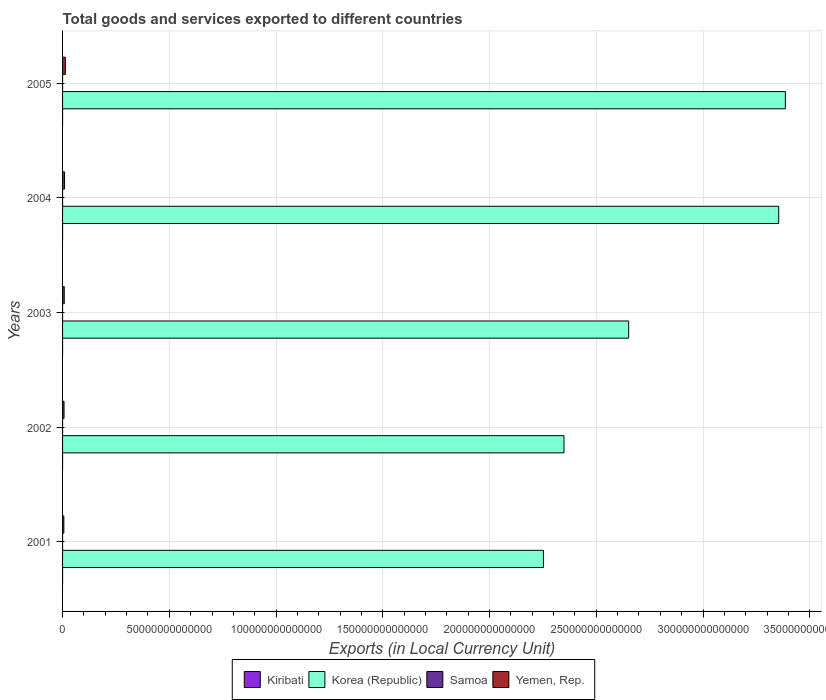How many different coloured bars are there?
Provide a short and direct response. 4. Are the number of bars on each tick of the Y-axis equal?
Offer a terse response. Yes. How many bars are there on the 1st tick from the bottom?
Provide a short and direct response. 4. In how many cases, is the number of bars for a given year not equal to the number of legend labels?
Give a very brief answer. 0. What is the Amount of goods and services exports in Korea (Republic) in 2004?
Your answer should be compact. 3.35e+14. Across all years, what is the maximum Amount of goods and services exports in Korea (Republic)?
Provide a short and direct response. 3.39e+14. Across all years, what is the minimum Amount of goods and services exports in Samoa?
Your answer should be compact. 2.88e+08. In which year was the Amount of goods and services exports in Samoa maximum?
Your answer should be compact. 2005. In which year was the Amount of goods and services exports in Kiribati minimum?
Offer a terse response. 2004. What is the total Amount of goods and services exports in Korea (Republic) in the graph?
Keep it short and to the point. 1.40e+15. What is the difference between the Amount of goods and services exports in Kiribati in 2001 and that in 2004?
Provide a succinct answer. 3.41e+06. What is the difference between the Amount of goods and services exports in Kiribati in 2005 and the Amount of goods and services exports in Korea (Republic) in 2002?
Your answer should be compact. -2.35e+14. What is the average Amount of goods and services exports in Yemen, Rep. per year?
Provide a succinct answer. 8.65e+11. In the year 2005, what is the difference between the Amount of goods and services exports in Yemen, Rep. and Amount of goods and services exports in Kiribati?
Provide a succinct answer. 1.31e+12. In how many years, is the Amount of goods and services exports in Kiribati greater than 320000000000000 LCU?
Provide a succinct answer. 0. What is the ratio of the Amount of goods and services exports in Kiribati in 2001 to that in 2002?
Your answer should be compact. 0.79. Is the difference between the Amount of goods and services exports in Yemen, Rep. in 2001 and 2003 greater than the difference between the Amount of goods and services exports in Kiribati in 2001 and 2003?
Your answer should be very brief. No. What is the difference between the highest and the second highest Amount of goods and services exports in Yemen, Rep.?
Give a very brief answer. 3.80e+11. What is the difference between the highest and the lowest Amount of goods and services exports in Yemen, Rep.?
Offer a very short reply. 7.16e+11. What does the 1st bar from the top in 2004 represents?
Provide a short and direct response. Yemen, Rep. What does the 4th bar from the bottom in 2005 represents?
Your answer should be compact. Yemen, Rep. Are all the bars in the graph horizontal?
Offer a terse response. Yes. How many years are there in the graph?
Your answer should be very brief. 5. What is the difference between two consecutive major ticks on the X-axis?
Ensure brevity in your answer.  5.00e+13. Are the values on the major ticks of X-axis written in scientific E-notation?
Make the answer very short. No. Does the graph contain grids?
Your answer should be very brief. Yes. Where does the legend appear in the graph?
Your answer should be very brief. Bottom center. How many legend labels are there?
Offer a terse response. 4. What is the title of the graph?
Ensure brevity in your answer.  Total goods and services exported to different countries. What is the label or title of the X-axis?
Provide a short and direct response. Exports (in Local Currency Unit). What is the label or title of the Y-axis?
Give a very brief answer. Years. What is the Exports (in Local Currency Unit) in Kiribati in 2001?
Make the answer very short. 1.96e+07. What is the Exports (in Local Currency Unit) in Korea (Republic) in 2001?
Give a very brief answer. 2.25e+14. What is the Exports (in Local Currency Unit) in Samoa in 2001?
Your answer should be very brief. 2.88e+08. What is the Exports (in Local Currency Unit) of Yemen, Rep. in 2001?
Your answer should be compact. 5.97e+11. What is the Exports (in Local Currency Unit) of Kiribati in 2002?
Keep it short and to the point. 2.48e+07. What is the Exports (in Local Currency Unit) in Korea (Republic) in 2002?
Provide a succinct answer. 2.35e+14. What is the Exports (in Local Currency Unit) of Samoa in 2002?
Ensure brevity in your answer.  2.93e+08. What is the Exports (in Local Currency Unit) in Yemen, Rep. in 2002?
Provide a short and direct response. 6.95e+11. What is the Exports (in Local Currency Unit) in Kiribati in 2003?
Provide a succinct answer. 2.30e+07. What is the Exports (in Local Currency Unit) in Korea (Republic) in 2003?
Provide a short and direct response. 2.65e+14. What is the Exports (in Local Currency Unit) in Samoa in 2003?
Your answer should be compact. 2.99e+08. What is the Exports (in Local Currency Unit) of Yemen, Rep. in 2003?
Give a very brief answer. 7.87e+11. What is the Exports (in Local Currency Unit) of Kiribati in 2004?
Your response must be concise. 1.62e+07. What is the Exports (in Local Currency Unit) of Korea (Republic) in 2004?
Offer a very short reply. 3.35e+14. What is the Exports (in Local Currency Unit) in Samoa in 2004?
Provide a short and direct response. 3.39e+08. What is the Exports (in Local Currency Unit) of Yemen, Rep. in 2004?
Provide a succinct answer. 9.33e+11. What is the Exports (in Local Currency Unit) of Kiribati in 2005?
Your answer should be compact. 1.96e+07. What is the Exports (in Local Currency Unit) of Korea (Republic) in 2005?
Provide a succinct answer. 3.39e+14. What is the Exports (in Local Currency Unit) of Samoa in 2005?
Your answer should be compact. 3.58e+08. What is the Exports (in Local Currency Unit) of Yemen, Rep. in 2005?
Your answer should be very brief. 1.31e+12. Across all years, what is the maximum Exports (in Local Currency Unit) of Kiribati?
Your answer should be very brief. 2.48e+07. Across all years, what is the maximum Exports (in Local Currency Unit) in Korea (Republic)?
Ensure brevity in your answer.  3.39e+14. Across all years, what is the maximum Exports (in Local Currency Unit) in Samoa?
Provide a short and direct response. 3.58e+08. Across all years, what is the maximum Exports (in Local Currency Unit) in Yemen, Rep.?
Your answer should be very brief. 1.31e+12. Across all years, what is the minimum Exports (in Local Currency Unit) in Kiribati?
Offer a very short reply. 1.62e+07. Across all years, what is the minimum Exports (in Local Currency Unit) in Korea (Republic)?
Offer a terse response. 2.25e+14. Across all years, what is the minimum Exports (in Local Currency Unit) of Samoa?
Give a very brief answer. 2.88e+08. Across all years, what is the minimum Exports (in Local Currency Unit) in Yemen, Rep.?
Make the answer very short. 5.97e+11. What is the total Exports (in Local Currency Unit) of Kiribati in the graph?
Make the answer very short. 1.03e+08. What is the total Exports (in Local Currency Unit) in Korea (Republic) in the graph?
Provide a succinct answer. 1.40e+15. What is the total Exports (in Local Currency Unit) in Samoa in the graph?
Your answer should be compact. 1.58e+09. What is the total Exports (in Local Currency Unit) in Yemen, Rep. in the graph?
Offer a terse response. 4.32e+12. What is the difference between the Exports (in Local Currency Unit) of Kiribati in 2001 and that in 2002?
Give a very brief answer. -5.25e+06. What is the difference between the Exports (in Local Currency Unit) of Korea (Republic) in 2001 and that in 2002?
Provide a short and direct response. -9.63e+12. What is the difference between the Exports (in Local Currency Unit) of Samoa in 2001 and that in 2002?
Keep it short and to the point. -4.68e+06. What is the difference between the Exports (in Local Currency Unit) of Yemen, Rep. in 2001 and that in 2002?
Give a very brief answer. -9.82e+1. What is the difference between the Exports (in Local Currency Unit) in Kiribati in 2001 and that in 2003?
Offer a very short reply. -3.41e+06. What is the difference between the Exports (in Local Currency Unit) of Korea (Republic) in 2001 and that in 2003?
Your response must be concise. -3.99e+13. What is the difference between the Exports (in Local Currency Unit) in Samoa in 2001 and that in 2003?
Provide a short and direct response. -1.08e+07. What is the difference between the Exports (in Local Currency Unit) of Yemen, Rep. in 2001 and that in 2003?
Provide a short and direct response. -1.91e+11. What is the difference between the Exports (in Local Currency Unit) of Kiribati in 2001 and that in 2004?
Make the answer very short. 3.41e+06. What is the difference between the Exports (in Local Currency Unit) in Korea (Republic) in 2001 and that in 2004?
Offer a terse response. -1.10e+14. What is the difference between the Exports (in Local Currency Unit) of Samoa in 2001 and that in 2004?
Offer a terse response. -5.04e+07. What is the difference between the Exports (in Local Currency Unit) in Yemen, Rep. in 2001 and that in 2004?
Provide a short and direct response. -3.36e+11. What is the difference between the Exports (in Local Currency Unit) of Kiribati in 2001 and that in 2005?
Provide a short and direct response. -3.68e+04. What is the difference between the Exports (in Local Currency Unit) of Korea (Republic) in 2001 and that in 2005?
Your answer should be very brief. -1.13e+14. What is the difference between the Exports (in Local Currency Unit) in Samoa in 2001 and that in 2005?
Keep it short and to the point. -7.00e+07. What is the difference between the Exports (in Local Currency Unit) in Yemen, Rep. in 2001 and that in 2005?
Your answer should be compact. -7.16e+11. What is the difference between the Exports (in Local Currency Unit) of Kiribati in 2002 and that in 2003?
Give a very brief answer. 1.84e+06. What is the difference between the Exports (in Local Currency Unit) in Korea (Republic) in 2002 and that in 2003?
Your answer should be compact. -3.03e+13. What is the difference between the Exports (in Local Currency Unit) in Samoa in 2002 and that in 2003?
Ensure brevity in your answer.  -6.08e+06. What is the difference between the Exports (in Local Currency Unit) of Yemen, Rep. in 2002 and that in 2003?
Provide a short and direct response. -9.24e+1. What is the difference between the Exports (in Local Currency Unit) of Kiribati in 2002 and that in 2004?
Make the answer very short. 8.66e+06. What is the difference between the Exports (in Local Currency Unit) in Korea (Republic) in 2002 and that in 2004?
Ensure brevity in your answer.  -1.01e+14. What is the difference between the Exports (in Local Currency Unit) of Samoa in 2002 and that in 2004?
Give a very brief answer. -4.57e+07. What is the difference between the Exports (in Local Currency Unit) of Yemen, Rep. in 2002 and that in 2004?
Your answer should be compact. -2.38e+11. What is the difference between the Exports (in Local Currency Unit) of Kiribati in 2002 and that in 2005?
Provide a short and direct response. 5.21e+06. What is the difference between the Exports (in Local Currency Unit) of Korea (Republic) in 2002 and that in 2005?
Provide a short and direct response. -1.04e+14. What is the difference between the Exports (in Local Currency Unit) in Samoa in 2002 and that in 2005?
Your answer should be very brief. -6.53e+07. What is the difference between the Exports (in Local Currency Unit) in Yemen, Rep. in 2002 and that in 2005?
Your answer should be very brief. -6.17e+11. What is the difference between the Exports (in Local Currency Unit) in Kiribati in 2003 and that in 2004?
Your response must be concise. 6.82e+06. What is the difference between the Exports (in Local Currency Unit) of Korea (Republic) in 2003 and that in 2004?
Offer a terse response. -7.03e+13. What is the difference between the Exports (in Local Currency Unit) in Samoa in 2003 and that in 2004?
Provide a succinct answer. -3.96e+07. What is the difference between the Exports (in Local Currency Unit) of Yemen, Rep. in 2003 and that in 2004?
Give a very brief answer. -1.45e+11. What is the difference between the Exports (in Local Currency Unit) of Kiribati in 2003 and that in 2005?
Provide a succinct answer. 3.37e+06. What is the difference between the Exports (in Local Currency Unit) of Korea (Republic) in 2003 and that in 2005?
Provide a short and direct response. -7.34e+13. What is the difference between the Exports (in Local Currency Unit) in Samoa in 2003 and that in 2005?
Give a very brief answer. -5.92e+07. What is the difference between the Exports (in Local Currency Unit) of Yemen, Rep. in 2003 and that in 2005?
Ensure brevity in your answer.  -5.25e+11. What is the difference between the Exports (in Local Currency Unit) of Kiribati in 2004 and that in 2005?
Your answer should be compact. -3.45e+06. What is the difference between the Exports (in Local Currency Unit) in Korea (Republic) in 2004 and that in 2005?
Offer a terse response. -3.10e+12. What is the difference between the Exports (in Local Currency Unit) of Samoa in 2004 and that in 2005?
Make the answer very short. -1.96e+07. What is the difference between the Exports (in Local Currency Unit) in Yemen, Rep. in 2004 and that in 2005?
Provide a short and direct response. -3.80e+11. What is the difference between the Exports (in Local Currency Unit) in Kiribati in 2001 and the Exports (in Local Currency Unit) in Korea (Republic) in 2002?
Give a very brief answer. -2.35e+14. What is the difference between the Exports (in Local Currency Unit) in Kiribati in 2001 and the Exports (in Local Currency Unit) in Samoa in 2002?
Ensure brevity in your answer.  -2.73e+08. What is the difference between the Exports (in Local Currency Unit) in Kiribati in 2001 and the Exports (in Local Currency Unit) in Yemen, Rep. in 2002?
Provide a short and direct response. -6.95e+11. What is the difference between the Exports (in Local Currency Unit) in Korea (Republic) in 2001 and the Exports (in Local Currency Unit) in Samoa in 2002?
Keep it short and to the point. 2.25e+14. What is the difference between the Exports (in Local Currency Unit) in Korea (Republic) in 2001 and the Exports (in Local Currency Unit) in Yemen, Rep. in 2002?
Provide a succinct answer. 2.25e+14. What is the difference between the Exports (in Local Currency Unit) in Samoa in 2001 and the Exports (in Local Currency Unit) in Yemen, Rep. in 2002?
Your answer should be compact. -6.95e+11. What is the difference between the Exports (in Local Currency Unit) of Kiribati in 2001 and the Exports (in Local Currency Unit) of Korea (Republic) in 2003?
Your answer should be compact. -2.65e+14. What is the difference between the Exports (in Local Currency Unit) of Kiribati in 2001 and the Exports (in Local Currency Unit) of Samoa in 2003?
Provide a short and direct response. -2.80e+08. What is the difference between the Exports (in Local Currency Unit) in Kiribati in 2001 and the Exports (in Local Currency Unit) in Yemen, Rep. in 2003?
Make the answer very short. -7.87e+11. What is the difference between the Exports (in Local Currency Unit) of Korea (Republic) in 2001 and the Exports (in Local Currency Unit) of Samoa in 2003?
Your answer should be compact. 2.25e+14. What is the difference between the Exports (in Local Currency Unit) of Korea (Republic) in 2001 and the Exports (in Local Currency Unit) of Yemen, Rep. in 2003?
Provide a succinct answer. 2.24e+14. What is the difference between the Exports (in Local Currency Unit) of Samoa in 2001 and the Exports (in Local Currency Unit) of Yemen, Rep. in 2003?
Ensure brevity in your answer.  -7.87e+11. What is the difference between the Exports (in Local Currency Unit) in Kiribati in 2001 and the Exports (in Local Currency Unit) in Korea (Republic) in 2004?
Offer a very short reply. -3.35e+14. What is the difference between the Exports (in Local Currency Unit) of Kiribati in 2001 and the Exports (in Local Currency Unit) of Samoa in 2004?
Offer a terse response. -3.19e+08. What is the difference between the Exports (in Local Currency Unit) in Kiribati in 2001 and the Exports (in Local Currency Unit) in Yemen, Rep. in 2004?
Offer a terse response. -9.33e+11. What is the difference between the Exports (in Local Currency Unit) of Korea (Republic) in 2001 and the Exports (in Local Currency Unit) of Samoa in 2004?
Provide a short and direct response. 2.25e+14. What is the difference between the Exports (in Local Currency Unit) in Korea (Republic) in 2001 and the Exports (in Local Currency Unit) in Yemen, Rep. in 2004?
Provide a succinct answer. 2.24e+14. What is the difference between the Exports (in Local Currency Unit) in Samoa in 2001 and the Exports (in Local Currency Unit) in Yemen, Rep. in 2004?
Make the answer very short. -9.32e+11. What is the difference between the Exports (in Local Currency Unit) in Kiribati in 2001 and the Exports (in Local Currency Unit) in Korea (Republic) in 2005?
Your response must be concise. -3.39e+14. What is the difference between the Exports (in Local Currency Unit) of Kiribati in 2001 and the Exports (in Local Currency Unit) of Samoa in 2005?
Provide a short and direct response. -3.39e+08. What is the difference between the Exports (in Local Currency Unit) in Kiribati in 2001 and the Exports (in Local Currency Unit) in Yemen, Rep. in 2005?
Your answer should be compact. -1.31e+12. What is the difference between the Exports (in Local Currency Unit) in Korea (Republic) in 2001 and the Exports (in Local Currency Unit) in Samoa in 2005?
Give a very brief answer. 2.25e+14. What is the difference between the Exports (in Local Currency Unit) of Korea (Republic) in 2001 and the Exports (in Local Currency Unit) of Yemen, Rep. in 2005?
Your answer should be compact. 2.24e+14. What is the difference between the Exports (in Local Currency Unit) of Samoa in 2001 and the Exports (in Local Currency Unit) of Yemen, Rep. in 2005?
Your response must be concise. -1.31e+12. What is the difference between the Exports (in Local Currency Unit) in Kiribati in 2002 and the Exports (in Local Currency Unit) in Korea (Republic) in 2003?
Keep it short and to the point. -2.65e+14. What is the difference between the Exports (in Local Currency Unit) of Kiribati in 2002 and the Exports (in Local Currency Unit) of Samoa in 2003?
Ensure brevity in your answer.  -2.74e+08. What is the difference between the Exports (in Local Currency Unit) of Kiribati in 2002 and the Exports (in Local Currency Unit) of Yemen, Rep. in 2003?
Provide a short and direct response. -7.87e+11. What is the difference between the Exports (in Local Currency Unit) in Korea (Republic) in 2002 and the Exports (in Local Currency Unit) in Samoa in 2003?
Your response must be concise. 2.35e+14. What is the difference between the Exports (in Local Currency Unit) of Korea (Republic) in 2002 and the Exports (in Local Currency Unit) of Yemen, Rep. in 2003?
Your answer should be compact. 2.34e+14. What is the difference between the Exports (in Local Currency Unit) of Samoa in 2002 and the Exports (in Local Currency Unit) of Yemen, Rep. in 2003?
Ensure brevity in your answer.  -7.87e+11. What is the difference between the Exports (in Local Currency Unit) of Kiribati in 2002 and the Exports (in Local Currency Unit) of Korea (Republic) in 2004?
Provide a succinct answer. -3.35e+14. What is the difference between the Exports (in Local Currency Unit) in Kiribati in 2002 and the Exports (in Local Currency Unit) in Samoa in 2004?
Ensure brevity in your answer.  -3.14e+08. What is the difference between the Exports (in Local Currency Unit) in Kiribati in 2002 and the Exports (in Local Currency Unit) in Yemen, Rep. in 2004?
Keep it short and to the point. -9.33e+11. What is the difference between the Exports (in Local Currency Unit) of Korea (Republic) in 2002 and the Exports (in Local Currency Unit) of Samoa in 2004?
Provide a short and direct response. 2.35e+14. What is the difference between the Exports (in Local Currency Unit) of Korea (Republic) in 2002 and the Exports (in Local Currency Unit) of Yemen, Rep. in 2004?
Offer a terse response. 2.34e+14. What is the difference between the Exports (in Local Currency Unit) in Samoa in 2002 and the Exports (in Local Currency Unit) in Yemen, Rep. in 2004?
Keep it short and to the point. -9.32e+11. What is the difference between the Exports (in Local Currency Unit) in Kiribati in 2002 and the Exports (in Local Currency Unit) in Korea (Republic) in 2005?
Make the answer very short. -3.39e+14. What is the difference between the Exports (in Local Currency Unit) of Kiribati in 2002 and the Exports (in Local Currency Unit) of Samoa in 2005?
Offer a very short reply. -3.34e+08. What is the difference between the Exports (in Local Currency Unit) in Kiribati in 2002 and the Exports (in Local Currency Unit) in Yemen, Rep. in 2005?
Ensure brevity in your answer.  -1.31e+12. What is the difference between the Exports (in Local Currency Unit) in Korea (Republic) in 2002 and the Exports (in Local Currency Unit) in Samoa in 2005?
Give a very brief answer. 2.35e+14. What is the difference between the Exports (in Local Currency Unit) in Korea (Republic) in 2002 and the Exports (in Local Currency Unit) in Yemen, Rep. in 2005?
Make the answer very short. 2.34e+14. What is the difference between the Exports (in Local Currency Unit) of Samoa in 2002 and the Exports (in Local Currency Unit) of Yemen, Rep. in 2005?
Your answer should be compact. -1.31e+12. What is the difference between the Exports (in Local Currency Unit) in Kiribati in 2003 and the Exports (in Local Currency Unit) in Korea (Republic) in 2004?
Ensure brevity in your answer.  -3.35e+14. What is the difference between the Exports (in Local Currency Unit) in Kiribati in 2003 and the Exports (in Local Currency Unit) in Samoa in 2004?
Offer a very short reply. -3.16e+08. What is the difference between the Exports (in Local Currency Unit) in Kiribati in 2003 and the Exports (in Local Currency Unit) in Yemen, Rep. in 2004?
Ensure brevity in your answer.  -9.33e+11. What is the difference between the Exports (in Local Currency Unit) of Korea (Republic) in 2003 and the Exports (in Local Currency Unit) of Samoa in 2004?
Offer a terse response. 2.65e+14. What is the difference between the Exports (in Local Currency Unit) in Korea (Republic) in 2003 and the Exports (in Local Currency Unit) in Yemen, Rep. in 2004?
Provide a succinct answer. 2.64e+14. What is the difference between the Exports (in Local Currency Unit) in Samoa in 2003 and the Exports (in Local Currency Unit) in Yemen, Rep. in 2004?
Provide a succinct answer. -9.32e+11. What is the difference between the Exports (in Local Currency Unit) in Kiribati in 2003 and the Exports (in Local Currency Unit) in Korea (Republic) in 2005?
Give a very brief answer. -3.39e+14. What is the difference between the Exports (in Local Currency Unit) in Kiribati in 2003 and the Exports (in Local Currency Unit) in Samoa in 2005?
Your answer should be compact. -3.35e+08. What is the difference between the Exports (in Local Currency Unit) of Kiribati in 2003 and the Exports (in Local Currency Unit) of Yemen, Rep. in 2005?
Offer a terse response. -1.31e+12. What is the difference between the Exports (in Local Currency Unit) of Korea (Republic) in 2003 and the Exports (in Local Currency Unit) of Samoa in 2005?
Make the answer very short. 2.65e+14. What is the difference between the Exports (in Local Currency Unit) in Korea (Republic) in 2003 and the Exports (in Local Currency Unit) in Yemen, Rep. in 2005?
Provide a short and direct response. 2.64e+14. What is the difference between the Exports (in Local Currency Unit) of Samoa in 2003 and the Exports (in Local Currency Unit) of Yemen, Rep. in 2005?
Your response must be concise. -1.31e+12. What is the difference between the Exports (in Local Currency Unit) of Kiribati in 2004 and the Exports (in Local Currency Unit) of Korea (Republic) in 2005?
Give a very brief answer. -3.39e+14. What is the difference between the Exports (in Local Currency Unit) in Kiribati in 2004 and the Exports (in Local Currency Unit) in Samoa in 2005?
Provide a short and direct response. -3.42e+08. What is the difference between the Exports (in Local Currency Unit) of Kiribati in 2004 and the Exports (in Local Currency Unit) of Yemen, Rep. in 2005?
Provide a short and direct response. -1.31e+12. What is the difference between the Exports (in Local Currency Unit) of Korea (Republic) in 2004 and the Exports (in Local Currency Unit) of Samoa in 2005?
Your answer should be very brief. 3.35e+14. What is the difference between the Exports (in Local Currency Unit) of Korea (Republic) in 2004 and the Exports (in Local Currency Unit) of Yemen, Rep. in 2005?
Make the answer very short. 3.34e+14. What is the difference between the Exports (in Local Currency Unit) of Samoa in 2004 and the Exports (in Local Currency Unit) of Yemen, Rep. in 2005?
Ensure brevity in your answer.  -1.31e+12. What is the average Exports (in Local Currency Unit) of Kiribati per year?
Offer a very short reply. 2.06e+07. What is the average Exports (in Local Currency Unit) of Korea (Republic) per year?
Offer a terse response. 2.80e+14. What is the average Exports (in Local Currency Unit) in Samoa per year?
Your answer should be compact. 3.16e+08. What is the average Exports (in Local Currency Unit) of Yemen, Rep. per year?
Make the answer very short. 8.65e+11. In the year 2001, what is the difference between the Exports (in Local Currency Unit) of Kiribati and Exports (in Local Currency Unit) of Korea (Republic)?
Offer a very short reply. -2.25e+14. In the year 2001, what is the difference between the Exports (in Local Currency Unit) of Kiribati and Exports (in Local Currency Unit) of Samoa?
Ensure brevity in your answer.  -2.69e+08. In the year 2001, what is the difference between the Exports (in Local Currency Unit) of Kiribati and Exports (in Local Currency Unit) of Yemen, Rep.?
Your answer should be very brief. -5.97e+11. In the year 2001, what is the difference between the Exports (in Local Currency Unit) in Korea (Republic) and Exports (in Local Currency Unit) in Samoa?
Keep it short and to the point. 2.25e+14. In the year 2001, what is the difference between the Exports (in Local Currency Unit) in Korea (Republic) and Exports (in Local Currency Unit) in Yemen, Rep.?
Keep it short and to the point. 2.25e+14. In the year 2001, what is the difference between the Exports (in Local Currency Unit) in Samoa and Exports (in Local Currency Unit) in Yemen, Rep.?
Provide a short and direct response. -5.96e+11. In the year 2002, what is the difference between the Exports (in Local Currency Unit) of Kiribati and Exports (in Local Currency Unit) of Korea (Republic)?
Give a very brief answer. -2.35e+14. In the year 2002, what is the difference between the Exports (in Local Currency Unit) of Kiribati and Exports (in Local Currency Unit) of Samoa?
Provide a succinct answer. -2.68e+08. In the year 2002, what is the difference between the Exports (in Local Currency Unit) of Kiribati and Exports (in Local Currency Unit) of Yemen, Rep.?
Make the answer very short. -6.95e+11. In the year 2002, what is the difference between the Exports (in Local Currency Unit) of Korea (Republic) and Exports (in Local Currency Unit) of Samoa?
Offer a very short reply. 2.35e+14. In the year 2002, what is the difference between the Exports (in Local Currency Unit) in Korea (Republic) and Exports (in Local Currency Unit) in Yemen, Rep.?
Keep it short and to the point. 2.34e+14. In the year 2002, what is the difference between the Exports (in Local Currency Unit) of Samoa and Exports (in Local Currency Unit) of Yemen, Rep.?
Provide a short and direct response. -6.95e+11. In the year 2003, what is the difference between the Exports (in Local Currency Unit) of Kiribati and Exports (in Local Currency Unit) of Korea (Republic)?
Offer a very short reply. -2.65e+14. In the year 2003, what is the difference between the Exports (in Local Currency Unit) of Kiribati and Exports (in Local Currency Unit) of Samoa?
Your response must be concise. -2.76e+08. In the year 2003, what is the difference between the Exports (in Local Currency Unit) of Kiribati and Exports (in Local Currency Unit) of Yemen, Rep.?
Provide a short and direct response. -7.87e+11. In the year 2003, what is the difference between the Exports (in Local Currency Unit) in Korea (Republic) and Exports (in Local Currency Unit) in Samoa?
Offer a terse response. 2.65e+14. In the year 2003, what is the difference between the Exports (in Local Currency Unit) of Korea (Republic) and Exports (in Local Currency Unit) of Yemen, Rep.?
Keep it short and to the point. 2.64e+14. In the year 2003, what is the difference between the Exports (in Local Currency Unit) in Samoa and Exports (in Local Currency Unit) in Yemen, Rep.?
Offer a very short reply. -7.87e+11. In the year 2004, what is the difference between the Exports (in Local Currency Unit) of Kiribati and Exports (in Local Currency Unit) of Korea (Republic)?
Your answer should be very brief. -3.35e+14. In the year 2004, what is the difference between the Exports (in Local Currency Unit) of Kiribati and Exports (in Local Currency Unit) of Samoa?
Your answer should be very brief. -3.23e+08. In the year 2004, what is the difference between the Exports (in Local Currency Unit) in Kiribati and Exports (in Local Currency Unit) in Yemen, Rep.?
Your response must be concise. -9.33e+11. In the year 2004, what is the difference between the Exports (in Local Currency Unit) of Korea (Republic) and Exports (in Local Currency Unit) of Samoa?
Provide a short and direct response. 3.35e+14. In the year 2004, what is the difference between the Exports (in Local Currency Unit) in Korea (Republic) and Exports (in Local Currency Unit) in Yemen, Rep.?
Offer a terse response. 3.35e+14. In the year 2004, what is the difference between the Exports (in Local Currency Unit) of Samoa and Exports (in Local Currency Unit) of Yemen, Rep.?
Offer a very short reply. -9.32e+11. In the year 2005, what is the difference between the Exports (in Local Currency Unit) of Kiribati and Exports (in Local Currency Unit) of Korea (Republic)?
Keep it short and to the point. -3.39e+14. In the year 2005, what is the difference between the Exports (in Local Currency Unit) of Kiribati and Exports (in Local Currency Unit) of Samoa?
Keep it short and to the point. -3.39e+08. In the year 2005, what is the difference between the Exports (in Local Currency Unit) in Kiribati and Exports (in Local Currency Unit) in Yemen, Rep.?
Offer a terse response. -1.31e+12. In the year 2005, what is the difference between the Exports (in Local Currency Unit) of Korea (Republic) and Exports (in Local Currency Unit) of Samoa?
Provide a short and direct response. 3.39e+14. In the year 2005, what is the difference between the Exports (in Local Currency Unit) in Korea (Republic) and Exports (in Local Currency Unit) in Yemen, Rep.?
Your response must be concise. 3.37e+14. In the year 2005, what is the difference between the Exports (in Local Currency Unit) of Samoa and Exports (in Local Currency Unit) of Yemen, Rep.?
Make the answer very short. -1.31e+12. What is the ratio of the Exports (in Local Currency Unit) of Kiribati in 2001 to that in 2002?
Your answer should be very brief. 0.79. What is the ratio of the Exports (in Local Currency Unit) in Korea (Republic) in 2001 to that in 2002?
Your response must be concise. 0.96. What is the ratio of the Exports (in Local Currency Unit) of Samoa in 2001 to that in 2002?
Keep it short and to the point. 0.98. What is the ratio of the Exports (in Local Currency Unit) of Yemen, Rep. in 2001 to that in 2002?
Make the answer very short. 0.86. What is the ratio of the Exports (in Local Currency Unit) in Kiribati in 2001 to that in 2003?
Your response must be concise. 0.85. What is the ratio of the Exports (in Local Currency Unit) in Korea (Republic) in 2001 to that in 2003?
Your response must be concise. 0.85. What is the ratio of the Exports (in Local Currency Unit) of Yemen, Rep. in 2001 to that in 2003?
Offer a very short reply. 0.76. What is the ratio of the Exports (in Local Currency Unit) in Kiribati in 2001 to that in 2004?
Offer a very short reply. 1.21. What is the ratio of the Exports (in Local Currency Unit) in Korea (Republic) in 2001 to that in 2004?
Give a very brief answer. 0.67. What is the ratio of the Exports (in Local Currency Unit) in Samoa in 2001 to that in 2004?
Your answer should be very brief. 0.85. What is the ratio of the Exports (in Local Currency Unit) in Yemen, Rep. in 2001 to that in 2004?
Offer a very short reply. 0.64. What is the ratio of the Exports (in Local Currency Unit) in Korea (Republic) in 2001 to that in 2005?
Provide a short and direct response. 0.67. What is the ratio of the Exports (in Local Currency Unit) of Samoa in 2001 to that in 2005?
Your response must be concise. 0.8. What is the ratio of the Exports (in Local Currency Unit) of Yemen, Rep. in 2001 to that in 2005?
Your answer should be very brief. 0.45. What is the ratio of the Exports (in Local Currency Unit) in Kiribati in 2002 to that in 2003?
Offer a very short reply. 1.08. What is the ratio of the Exports (in Local Currency Unit) in Korea (Republic) in 2002 to that in 2003?
Provide a short and direct response. 0.89. What is the ratio of the Exports (in Local Currency Unit) in Samoa in 2002 to that in 2003?
Your answer should be very brief. 0.98. What is the ratio of the Exports (in Local Currency Unit) in Yemen, Rep. in 2002 to that in 2003?
Offer a terse response. 0.88. What is the ratio of the Exports (in Local Currency Unit) in Kiribati in 2002 to that in 2004?
Make the answer very short. 1.54. What is the ratio of the Exports (in Local Currency Unit) in Korea (Republic) in 2002 to that in 2004?
Give a very brief answer. 0.7. What is the ratio of the Exports (in Local Currency Unit) of Samoa in 2002 to that in 2004?
Your answer should be very brief. 0.87. What is the ratio of the Exports (in Local Currency Unit) in Yemen, Rep. in 2002 to that in 2004?
Keep it short and to the point. 0.75. What is the ratio of the Exports (in Local Currency Unit) of Kiribati in 2002 to that in 2005?
Make the answer very short. 1.27. What is the ratio of the Exports (in Local Currency Unit) in Korea (Republic) in 2002 to that in 2005?
Ensure brevity in your answer.  0.69. What is the ratio of the Exports (in Local Currency Unit) of Samoa in 2002 to that in 2005?
Offer a very short reply. 0.82. What is the ratio of the Exports (in Local Currency Unit) of Yemen, Rep. in 2002 to that in 2005?
Keep it short and to the point. 0.53. What is the ratio of the Exports (in Local Currency Unit) in Kiribati in 2003 to that in 2004?
Your answer should be very brief. 1.42. What is the ratio of the Exports (in Local Currency Unit) in Korea (Republic) in 2003 to that in 2004?
Keep it short and to the point. 0.79. What is the ratio of the Exports (in Local Currency Unit) of Samoa in 2003 to that in 2004?
Offer a very short reply. 0.88. What is the ratio of the Exports (in Local Currency Unit) in Yemen, Rep. in 2003 to that in 2004?
Offer a very short reply. 0.84. What is the ratio of the Exports (in Local Currency Unit) of Kiribati in 2003 to that in 2005?
Offer a very short reply. 1.17. What is the ratio of the Exports (in Local Currency Unit) in Korea (Republic) in 2003 to that in 2005?
Your answer should be very brief. 0.78. What is the ratio of the Exports (in Local Currency Unit) in Samoa in 2003 to that in 2005?
Provide a short and direct response. 0.83. What is the ratio of the Exports (in Local Currency Unit) of Yemen, Rep. in 2003 to that in 2005?
Ensure brevity in your answer.  0.6. What is the ratio of the Exports (in Local Currency Unit) of Kiribati in 2004 to that in 2005?
Your answer should be compact. 0.82. What is the ratio of the Exports (in Local Currency Unit) in Korea (Republic) in 2004 to that in 2005?
Your response must be concise. 0.99. What is the ratio of the Exports (in Local Currency Unit) in Samoa in 2004 to that in 2005?
Give a very brief answer. 0.95. What is the ratio of the Exports (in Local Currency Unit) of Yemen, Rep. in 2004 to that in 2005?
Offer a very short reply. 0.71. What is the difference between the highest and the second highest Exports (in Local Currency Unit) of Kiribati?
Ensure brevity in your answer.  1.84e+06. What is the difference between the highest and the second highest Exports (in Local Currency Unit) of Korea (Republic)?
Keep it short and to the point. 3.10e+12. What is the difference between the highest and the second highest Exports (in Local Currency Unit) in Samoa?
Ensure brevity in your answer.  1.96e+07. What is the difference between the highest and the second highest Exports (in Local Currency Unit) in Yemen, Rep.?
Provide a short and direct response. 3.80e+11. What is the difference between the highest and the lowest Exports (in Local Currency Unit) of Kiribati?
Give a very brief answer. 8.66e+06. What is the difference between the highest and the lowest Exports (in Local Currency Unit) in Korea (Republic)?
Your answer should be compact. 1.13e+14. What is the difference between the highest and the lowest Exports (in Local Currency Unit) of Samoa?
Your response must be concise. 7.00e+07. What is the difference between the highest and the lowest Exports (in Local Currency Unit) in Yemen, Rep.?
Ensure brevity in your answer.  7.16e+11. 